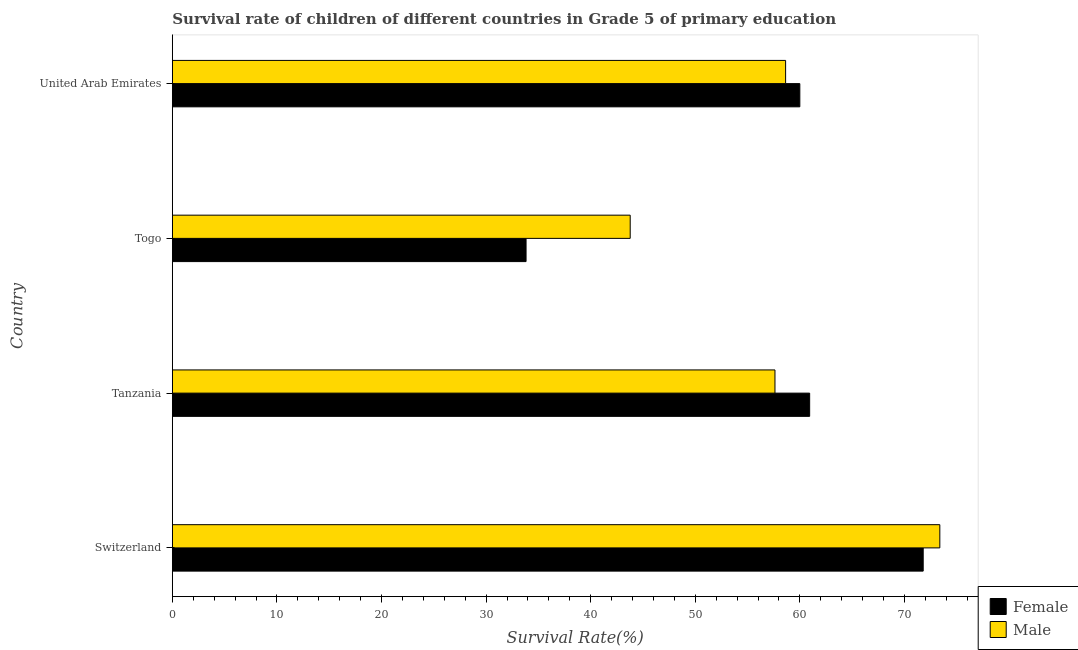How many bars are there on the 1st tick from the top?
Give a very brief answer. 2. What is the label of the 2nd group of bars from the top?
Ensure brevity in your answer.  Togo. In how many cases, is the number of bars for a given country not equal to the number of legend labels?
Your answer should be very brief. 0. What is the survival rate of male students in primary education in United Arab Emirates?
Ensure brevity in your answer.  58.64. Across all countries, what is the maximum survival rate of female students in primary education?
Your answer should be very brief. 71.8. Across all countries, what is the minimum survival rate of male students in primary education?
Your response must be concise. 43.78. In which country was the survival rate of female students in primary education maximum?
Offer a very short reply. Switzerland. In which country was the survival rate of male students in primary education minimum?
Offer a very short reply. Togo. What is the total survival rate of male students in primary education in the graph?
Your answer should be compact. 233.43. What is the difference between the survival rate of male students in primary education in Switzerland and that in Togo?
Ensure brevity in your answer.  29.61. What is the difference between the survival rate of female students in primary education in Togo and the survival rate of male students in primary education in Switzerland?
Provide a succinct answer. -39.56. What is the average survival rate of male students in primary education per country?
Make the answer very short. 58.36. What is the difference between the survival rate of female students in primary education and survival rate of male students in primary education in Togo?
Ensure brevity in your answer.  -9.96. In how many countries, is the survival rate of female students in primary education greater than 54 %?
Your response must be concise. 3. What is the ratio of the survival rate of male students in primary education in Switzerland to that in United Arab Emirates?
Keep it short and to the point. 1.25. Is the survival rate of female students in primary education in Togo less than that in United Arab Emirates?
Provide a short and direct response. Yes. Is the difference between the survival rate of female students in primary education in Switzerland and United Arab Emirates greater than the difference between the survival rate of male students in primary education in Switzerland and United Arab Emirates?
Make the answer very short. No. What is the difference between the highest and the second highest survival rate of male students in primary education?
Your response must be concise. 14.75. What is the difference between the highest and the lowest survival rate of female students in primary education?
Make the answer very short. 37.97. In how many countries, is the survival rate of female students in primary education greater than the average survival rate of female students in primary education taken over all countries?
Keep it short and to the point. 3. How many bars are there?
Your response must be concise. 8. Are all the bars in the graph horizontal?
Provide a succinct answer. Yes. How many countries are there in the graph?
Make the answer very short. 4. What is the difference between two consecutive major ticks on the X-axis?
Keep it short and to the point. 10. Does the graph contain any zero values?
Keep it short and to the point. No. Does the graph contain grids?
Ensure brevity in your answer.  No. Where does the legend appear in the graph?
Keep it short and to the point. Bottom right. How many legend labels are there?
Provide a short and direct response. 2. What is the title of the graph?
Your response must be concise. Survival rate of children of different countries in Grade 5 of primary education. Does "Food" appear as one of the legend labels in the graph?
Give a very brief answer. No. What is the label or title of the X-axis?
Keep it short and to the point. Survival Rate(%). What is the label or title of the Y-axis?
Provide a short and direct response. Country. What is the Survival Rate(%) of Female in Switzerland?
Make the answer very short. 71.8. What is the Survival Rate(%) of Male in Switzerland?
Offer a very short reply. 73.39. What is the Survival Rate(%) in Female in Tanzania?
Keep it short and to the point. 60.94. What is the Survival Rate(%) of Male in Tanzania?
Your answer should be compact. 57.62. What is the Survival Rate(%) in Female in Togo?
Make the answer very short. 33.82. What is the Survival Rate(%) of Male in Togo?
Offer a terse response. 43.78. What is the Survival Rate(%) of Female in United Arab Emirates?
Ensure brevity in your answer.  60. What is the Survival Rate(%) of Male in United Arab Emirates?
Your answer should be compact. 58.64. Across all countries, what is the maximum Survival Rate(%) in Female?
Your response must be concise. 71.8. Across all countries, what is the maximum Survival Rate(%) in Male?
Offer a terse response. 73.39. Across all countries, what is the minimum Survival Rate(%) in Female?
Offer a very short reply. 33.82. Across all countries, what is the minimum Survival Rate(%) in Male?
Offer a terse response. 43.78. What is the total Survival Rate(%) of Female in the graph?
Make the answer very short. 226.56. What is the total Survival Rate(%) in Male in the graph?
Keep it short and to the point. 233.43. What is the difference between the Survival Rate(%) of Female in Switzerland and that in Tanzania?
Your answer should be very brief. 10.86. What is the difference between the Survival Rate(%) in Male in Switzerland and that in Tanzania?
Your answer should be very brief. 15.76. What is the difference between the Survival Rate(%) in Female in Switzerland and that in Togo?
Your answer should be compact. 37.97. What is the difference between the Survival Rate(%) in Male in Switzerland and that in Togo?
Your answer should be very brief. 29.61. What is the difference between the Survival Rate(%) of Female in Switzerland and that in United Arab Emirates?
Your answer should be very brief. 11.8. What is the difference between the Survival Rate(%) of Male in Switzerland and that in United Arab Emirates?
Give a very brief answer. 14.75. What is the difference between the Survival Rate(%) in Female in Tanzania and that in Togo?
Provide a short and direct response. 27.12. What is the difference between the Survival Rate(%) in Male in Tanzania and that in Togo?
Keep it short and to the point. 13.84. What is the difference between the Survival Rate(%) of Female in Tanzania and that in United Arab Emirates?
Provide a short and direct response. 0.94. What is the difference between the Survival Rate(%) of Male in Tanzania and that in United Arab Emirates?
Your answer should be compact. -1.02. What is the difference between the Survival Rate(%) of Female in Togo and that in United Arab Emirates?
Offer a terse response. -26.18. What is the difference between the Survival Rate(%) in Male in Togo and that in United Arab Emirates?
Provide a short and direct response. -14.86. What is the difference between the Survival Rate(%) in Female in Switzerland and the Survival Rate(%) in Male in Tanzania?
Make the answer very short. 14.17. What is the difference between the Survival Rate(%) in Female in Switzerland and the Survival Rate(%) in Male in Togo?
Offer a very short reply. 28.02. What is the difference between the Survival Rate(%) of Female in Switzerland and the Survival Rate(%) of Male in United Arab Emirates?
Your answer should be compact. 13.16. What is the difference between the Survival Rate(%) of Female in Tanzania and the Survival Rate(%) of Male in Togo?
Provide a short and direct response. 17.16. What is the difference between the Survival Rate(%) in Female in Tanzania and the Survival Rate(%) in Male in United Arab Emirates?
Make the answer very short. 2.3. What is the difference between the Survival Rate(%) in Female in Togo and the Survival Rate(%) in Male in United Arab Emirates?
Provide a succinct answer. -24.82. What is the average Survival Rate(%) of Female per country?
Offer a terse response. 56.64. What is the average Survival Rate(%) in Male per country?
Offer a very short reply. 58.36. What is the difference between the Survival Rate(%) of Female and Survival Rate(%) of Male in Switzerland?
Provide a short and direct response. -1.59. What is the difference between the Survival Rate(%) of Female and Survival Rate(%) of Male in Tanzania?
Your answer should be very brief. 3.32. What is the difference between the Survival Rate(%) in Female and Survival Rate(%) in Male in Togo?
Ensure brevity in your answer.  -9.96. What is the difference between the Survival Rate(%) in Female and Survival Rate(%) in Male in United Arab Emirates?
Offer a very short reply. 1.36. What is the ratio of the Survival Rate(%) of Female in Switzerland to that in Tanzania?
Give a very brief answer. 1.18. What is the ratio of the Survival Rate(%) of Male in Switzerland to that in Tanzania?
Offer a very short reply. 1.27. What is the ratio of the Survival Rate(%) of Female in Switzerland to that in Togo?
Your response must be concise. 2.12. What is the ratio of the Survival Rate(%) in Male in Switzerland to that in Togo?
Your answer should be compact. 1.68. What is the ratio of the Survival Rate(%) in Female in Switzerland to that in United Arab Emirates?
Give a very brief answer. 1.2. What is the ratio of the Survival Rate(%) of Male in Switzerland to that in United Arab Emirates?
Your answer should be compact. 1.25. What is the ratio of the Survival Rate(%) of Female in Tanzania to that in Togo?
Keep it short and to the point. 1.8. What is the ratio of the Survival Rate(%) in Male in Tanzania to that in Togo?
Provide a short and direct response. 1.32. What is the ratio of the Survival Rate(%) in Female in Tanzania to that in United Arab Emirates?
Give a very brief answer. 1.02. What is the ratio of the Survival Rate(%) in Male in Tanzania to that in United Arab Emirates?
Your response must be concise. 0.98. What is the ratio of the Survival Rate(%) of Female in Togo to that in United Arab Emirates?
Provide a short and direct response. 0.56. What is the ratio of the Survival Rate(%) in Male in Togo to that in United Arab Emirates?
Provide a succinct answer. 0.75. What is the difference between the highest and the second highest Survival Rate(%) of Female?
Your response must be concise. 10.86. What is the difference between the highest and the second highest Survival Rate(%) of Male?
Your answer should be very brief. 14.75. What is the difference between the highest and the lowest Survival Rate(%) in Female?
Make the answer very short. 37.97. What is the difference between the highest and the lowest Survival Rate(%) of Male?
Keep it short and to the point. 29.61. 